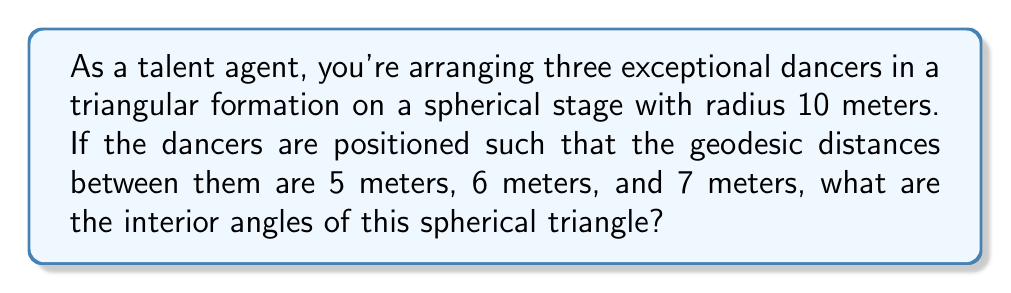Help me with this question. To solve this problem, we need to use spherical trigonometry. Let's approach this step-by-step:

1) In spherical geometry, we use the spherical law of cosines to find angles given the side lengths. The formula is:

   $$\cos(c) = \cos(a)\cos(b) + \sin(a)\sin(b)\cos(C)$$

   Where $a$, $b$, and $c$ are the side lengths (as angles at the center), and $C$ is the angle opposite to side $c$.

2) First, we need to convert the given distances to central angles. On a sphere with radius $R$, the central angle $\theta$ for an arc length $s$ is given by:

   $$\theta = \frac{s}{R}$$

3) Converting our side lengths:
   
   $a = \frac{5}{10} = 0.5$ radians
   $b = \frac{6}{10} = 0.6$ radians
   $c = \frac{7}{10} = 0.7$ radians

4) Now we can use the spherical law of cosines to find angle $C$:

   $$\cos(0.7) = \cos(0.5)\cos(0.6) + \sin(0.5)\sin(0.6)\cos(C)$$

5) Solving for $C$:

   $$\cos(C) = \frac{\cos(0.7) - \cos(0.5)\cos(0.6)}{\sin(0.5)\sin(0.6)}$$

6) Using a calculator or computer:

   $C \approx 1.2490$ radians or $71.59°$

7) We can repeat this process for angles $A$ and $B$:

   For $A$: $$\cos(A) = \frac{\cos(0.6) - \cos(0.5)\cos(0.7)}{\sin(0.5)\sin(0.7)}$$
   $A \approx 1.0472$ radians or $60.00°$

   For $B$: $$\cos(B) = \frac{\cos(0.5) - \cos(0.6)\cos(0.7)}{\sin(0.6)\sin(0.7)}$$
   $B \approx 0.8378$ radians or $48.01°$

8) Note that the sum of these angles is greater than 180°, which is a characteristic property of spherical triangles.
Answer: $A \approx 60.00°$, $B \approx 48.01°$, $C \approx 71.59°$ 